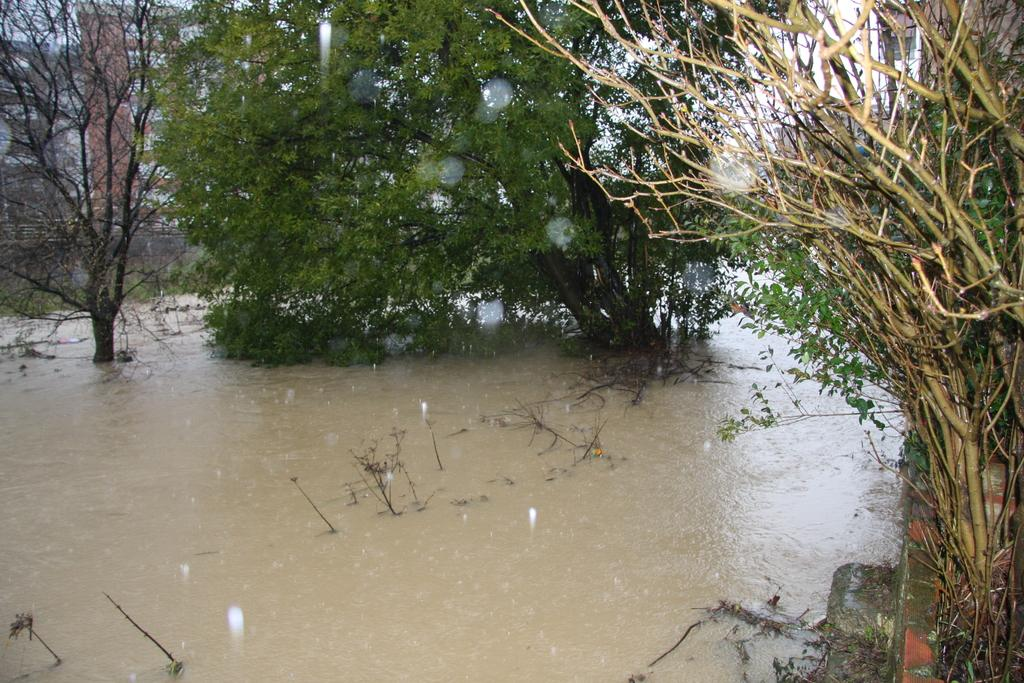What type of vegetation can be seen in the image? There are trees in the image. What natural element is visible in the image? There is water visible in the image. What type of cloud can be seen in the image? There is no cloud present in the image; it only features trees and water. What type of waste can be seen in the image? There is no waste present in the image; it only features trees and water. 